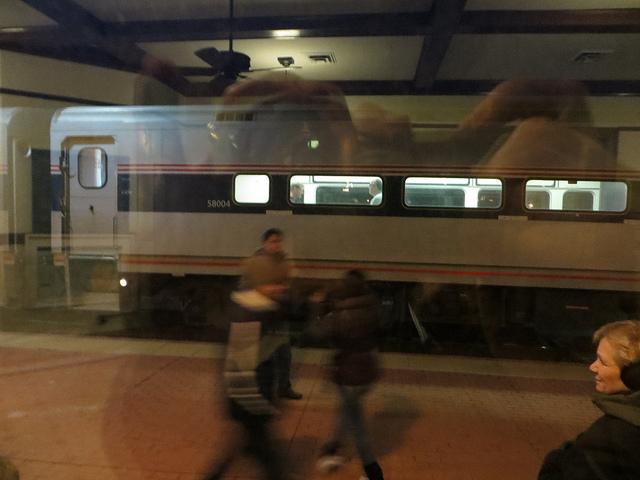Did the train just depart or arrive?
Short answer required. Arrive. Who is wearing earmuffs?
Write a very short answer. Woman. What is the image quality?
Give a very brief answer. Blurry. 